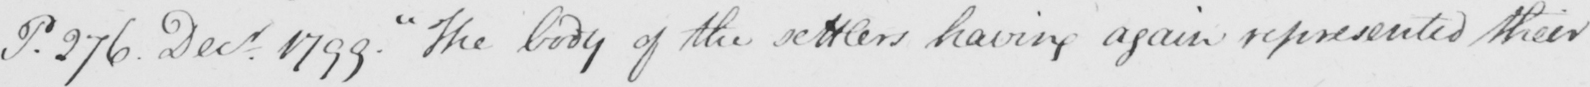What is written in this line of handwriting? P . 276 . Decr . 1799 .  " The body of the settlers having again represented their 